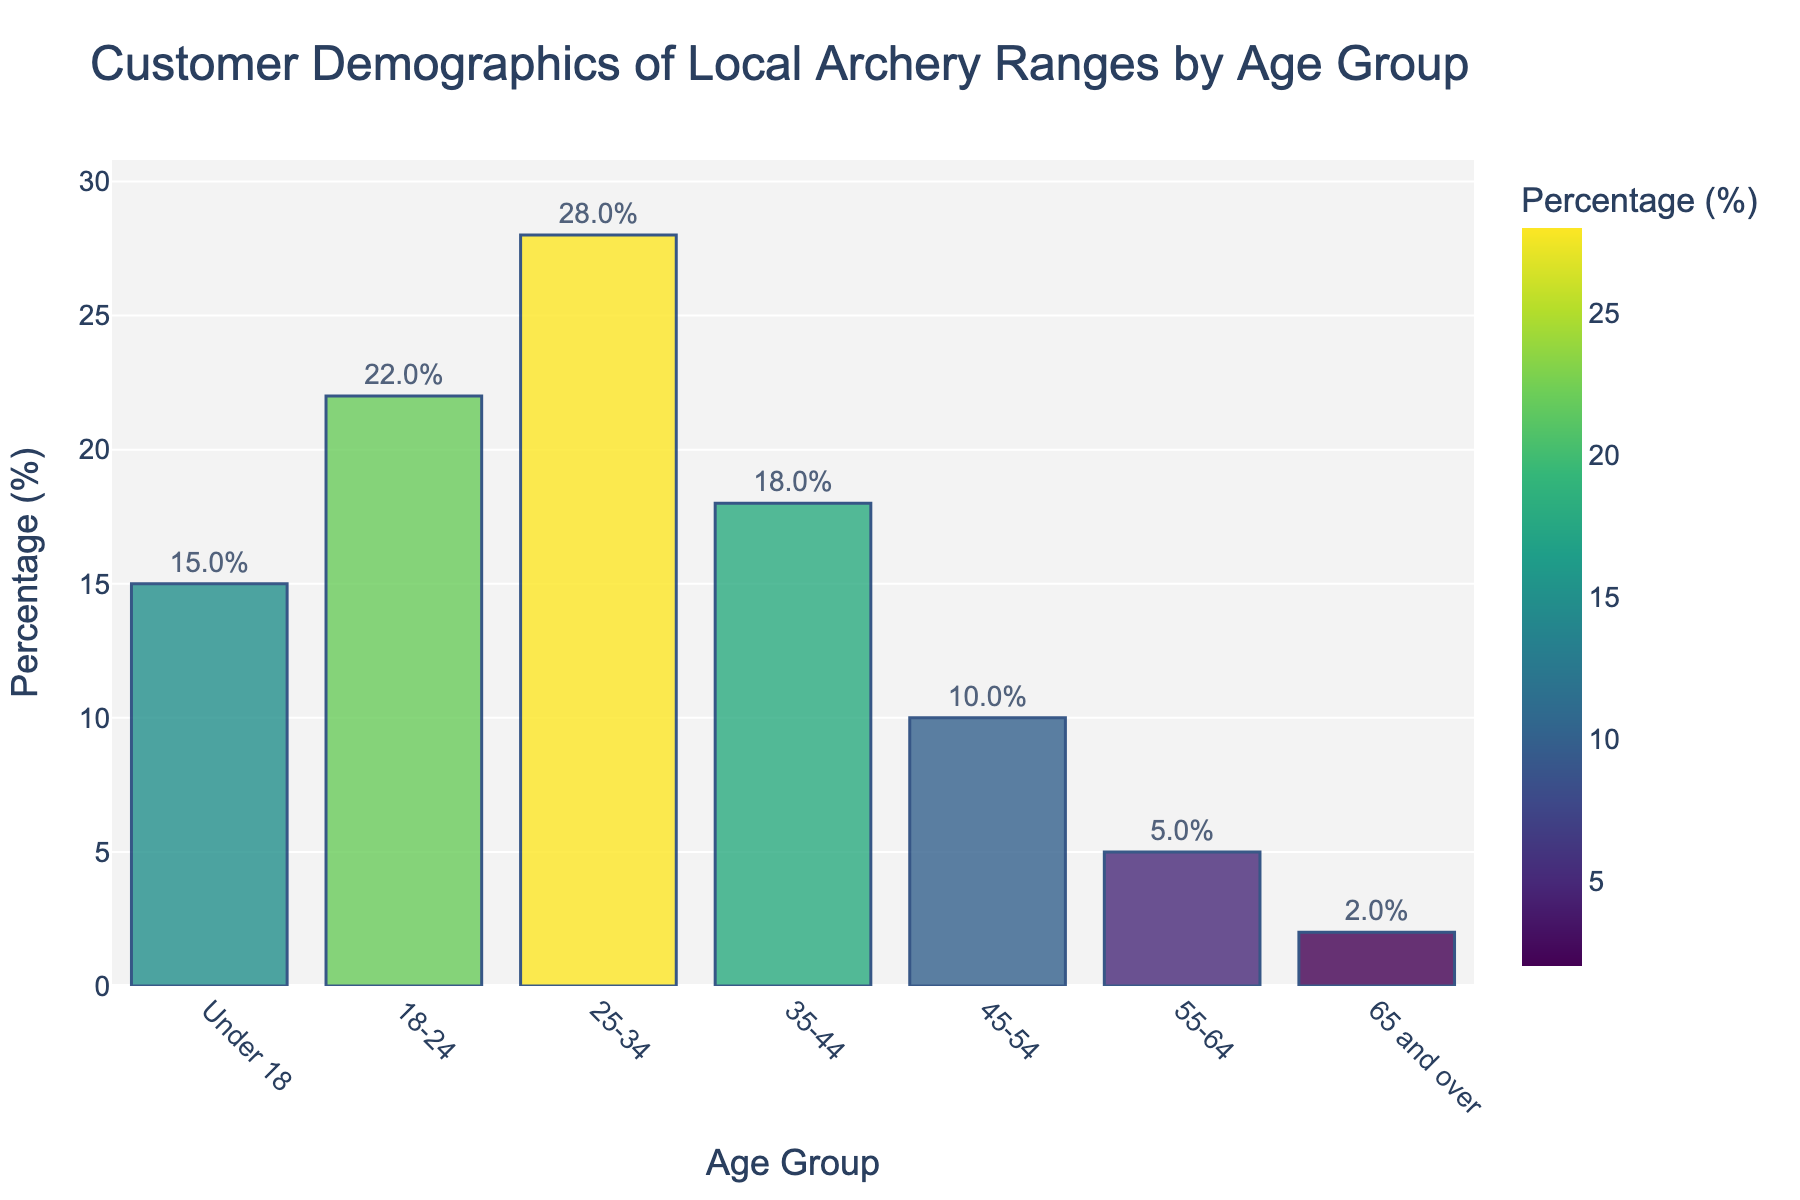Which age group has the highest percentage of customers at local archery ranges? By looking at the height of the bars, we can see that the tallest bar represents the 25-34 age group, indicating it has the highest percentage of customers.
Answer: 25-34 What is the combined percentage of customers aged 18-24 and 25-34? Add the percentages of the 18-24 and 25-34 age groups. The 18-24 age group has 22% and the 25-34 age group has 28%. So, 22% + 28% = 50%.
Answer: 50% Which age group has a lower percentage of customers: 35-44 or 45-54? Compare the height of the bars for the 35-44 and 45-54 age groups. The bar for 45-54 is shorter, indicating a lower percentage. 35-44 has 18% and 45-54 has 10%.
Answer: 45-54 What is the percentage difference between the 25-34 and 55-64 age groups? Subtract the percentage of the 55-64 age group from the percentage of the 25-34 age group. 25-34 has 28% and 55-64 has 5%. So, 28% - 5% = 23%.
Answer: 23% Which age group represents less than 5% of the total customer base? Look for bars that represent less than 5%. The bar for the age group '65 and over' represents 2%, which is less than 5%.
Answer: 65 and over How does the percentage of customers under 18 compare to those aged 45-54? Compare the height of the bars for the 'Under 18' and '45-54' age groups. Under 18 has 15% and 45-54 has 10%. The 'Under 18' group has a higher percentage.
Answer: Higher What is the average percentage of the customers in the age groups under 18, 18-24, and 25-34? First, add the percentages of the three age groups: 15% (Under 18) + 22% (18-24) + 28% (25-34) = 65%. Then divide by the number of age groups which is 3. So, 65% / 3 ≈ 21.67%.
Answer: 21.67% Which age group falls between 35-44 and 55-64 in percentage? Look at the heights of the bars for the 35-44 and 55-64 age groups and find the one in between. 35-44 has 18% and 55-64 has 5%. The age group 45-54, with 10%, falls between these percentages.
Answer: 45-54 